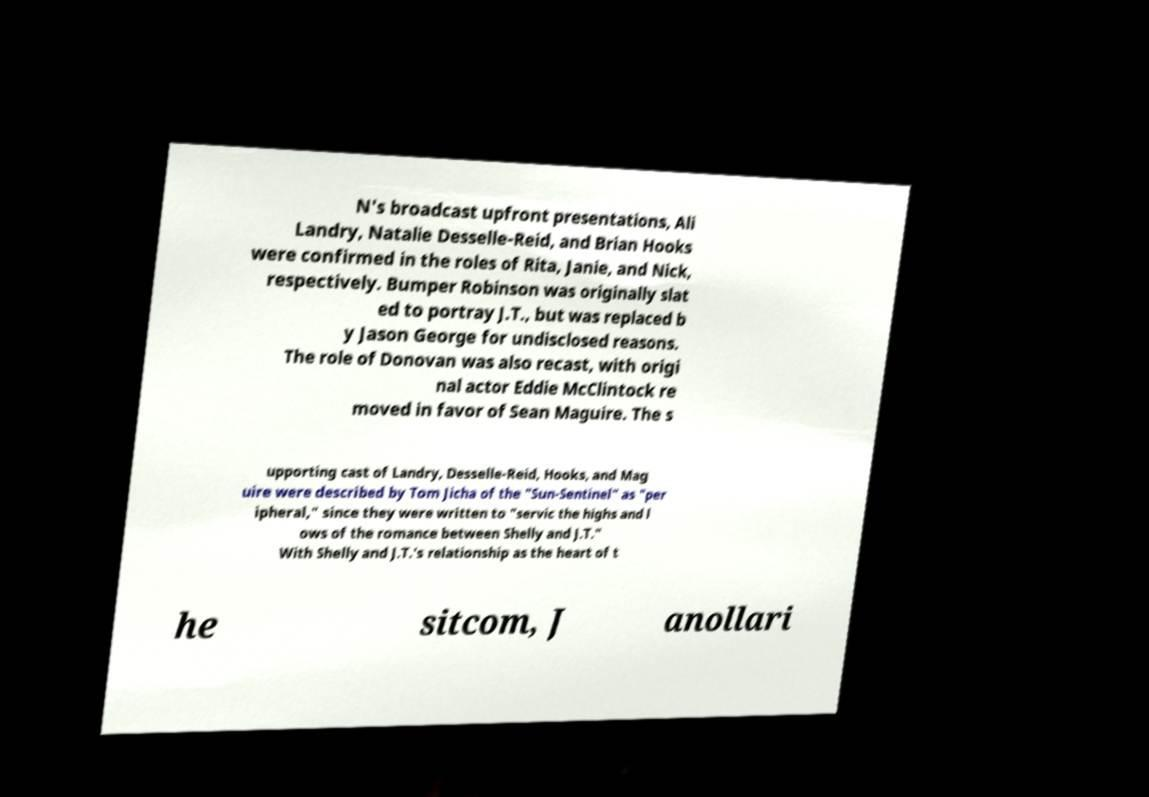What messages or text are displayed in this image? I need them in a readable, typed format. N's broadcast upfront presentations, Ali Landry, Natalie Desselle-Reid, and Brian Hooks were confirmed in the roles of Rita, Janie, and Nick, respectively. Bumper Robinson was originally slat ed to portray J.T., but was replaced b y Jason George for undisclosed reasons. The role of Donovan was also recast, with origi nal actor Eddie McClintock re moved in favor of Sean Maguire. The s upporting cast of Landry, Desselle-Reid, Hooks, and Mag uire were described by Tom Jicha of the "Sun-Sentinel" as "per ipheral," since they were written to "servic the highs and l ows of the romance between Shelly and J.T." With Shelly and J.T.'s relationship as the heart of t he sitcom, J anollari 